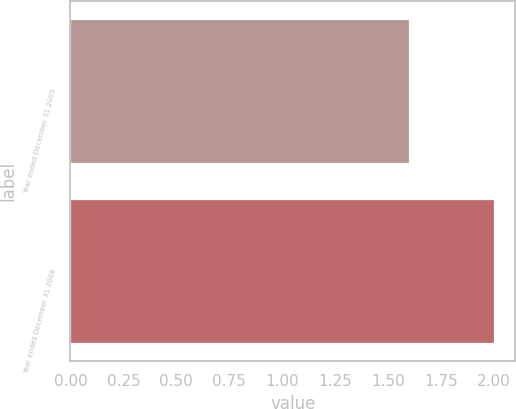<chart> <loc_0><loc_0><loc_500><loc_500><bar_chart><fcel>Year ended December 31 2009<fcel>Year ended December 31 2008<nl><fcel>1.6<fcel>2<nl></chart> 